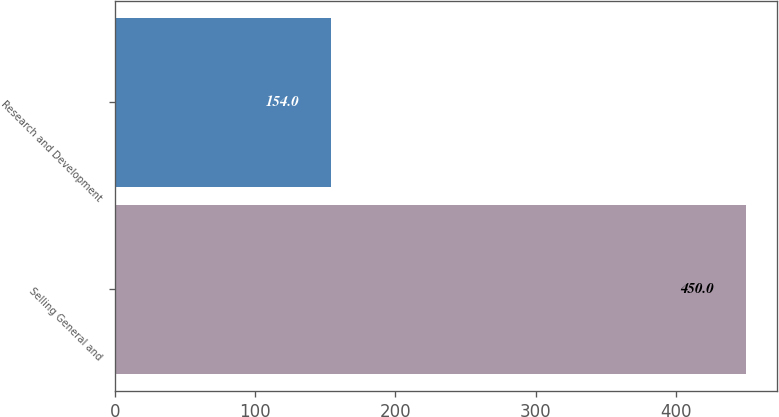Convert chart. <chart><loc_0><loc_0><loc_500><loc_500><bar_chart><fcel>Selling General and<fcel>Research and Development<nl><fcel>450<fcel>154<nl></chart> 